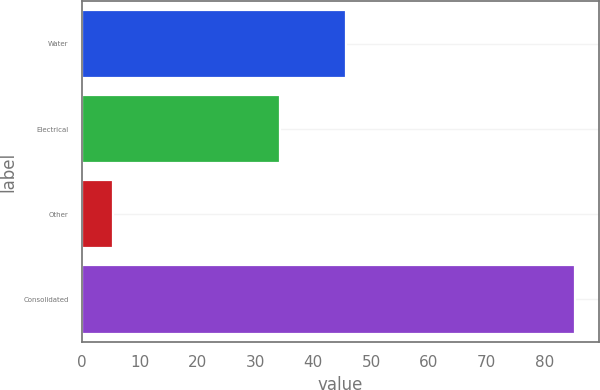Convert chart to OTSL. <chart><loc_0><loc_0><loc_500><loc_500><bar_chart><fcel>Water<fcel>Electrical<fcel>Other<fcel>Consolidated<nl><fcel>45.6<fcel>34.3<fcel>5.3<fcel>85.2<nl></chart> 